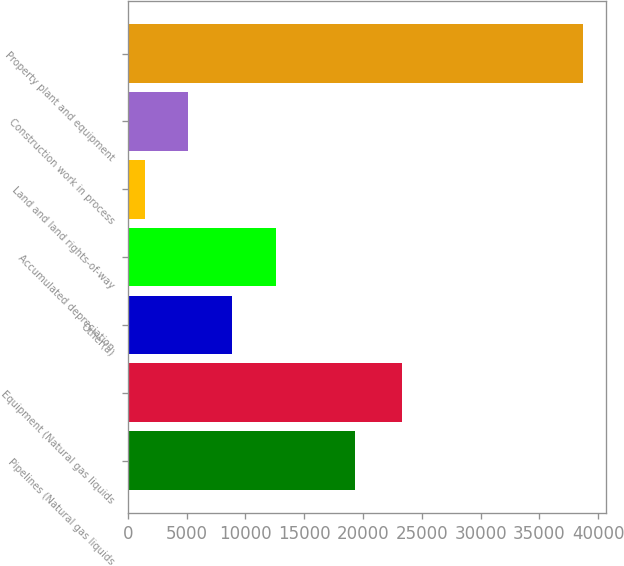Convert chart to OTSL. <chart><loc_0><loc_0><loc_500><loc_500><bar_chart><fcel>Pipelines (Natural gas liquids<fcel>Equipment (Natural gas liquids<fcel>Other(a)<fcel>Accumulated depreciation<fcel>Land and land rights-of-way<fcel>Construction work in process<fcel>Property plant and equipment<nl><fcel>19341<fcel>23298<fcel>8885.8<fcel>12613.2<fcel>1431<fcel>5158.4<fcel>38705<nl></chart> 